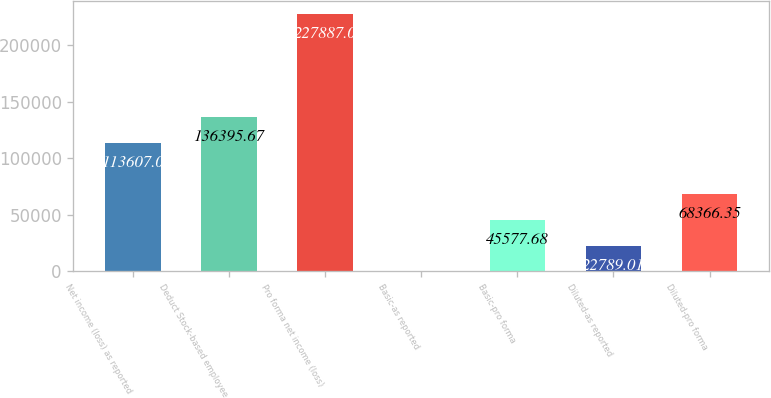<chart> <loc_0><loc_0><loc_500><loc_500><bar_chart><fcel>Net income (loss) as reported<fcel>Deduct Stock-based employee<fcel>Pro forma net income (loss)<fcel>Basic-as reported<fcel>Basic-pro forma<fcel>Diluted-as reported<fcel>Diluted-pro forma<nl><fcel>113607<fcel>136396<fcel>227887<fcel>0.34<fcel>45577.7<fcel>22789<fcel>68366.4<nl></chart> 